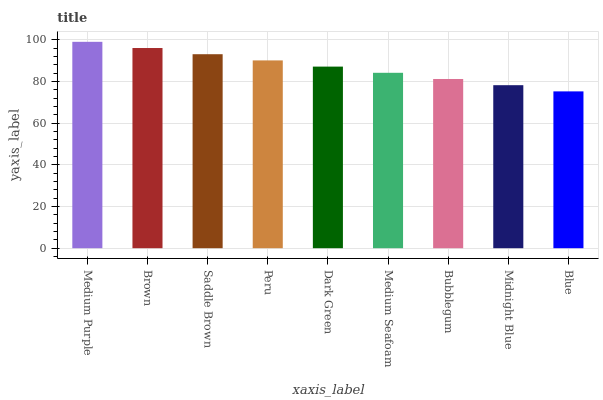Is Brown the minimum?
Answer yes or no. No. Is Brown the maximum?
Answer yes or no. No. Is Medium Purple greater than Brown?
Answer yes or no. Yes. Is Brown less than Medium Purple?
Answer yes or no. Yes. Is Brown greater than Medium Purple?
Answer yes or no. No. Is Medium Purple less than Brown?
Answer yes or no. No. Is Dark Green the high median?
Answer yes or no. Yes. Is Dark Green the low median?
Answer yes or no. Yes. Is Midnight Blue the high median?
Answer yes or no. No. Is Saddle Brown the low median?
Answer yes or no. No. 